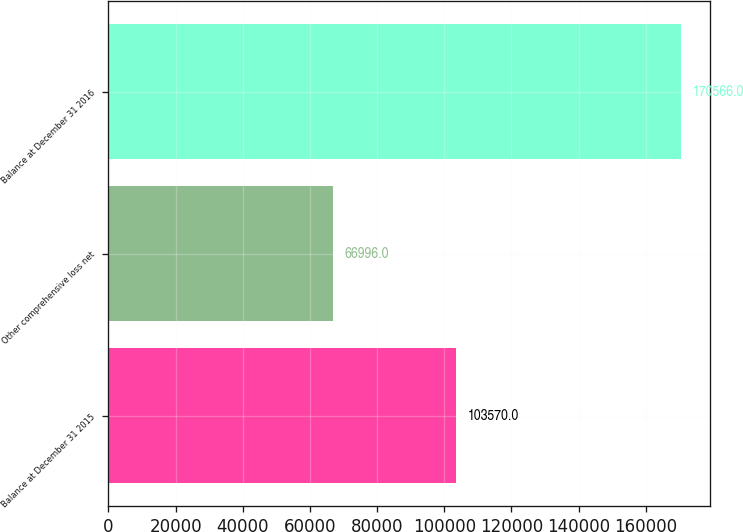Convert chart to OTSL. <chart><loc_0><loc_0><loc_500><loc_500><bar_chart><fcel>Balance at December 31 2015<fcel>Other comprehensive loss net<fcel>Balance at December 31 2016<nl><fcel>103570<fcel>66996<fcel>170566<nl></chart> 